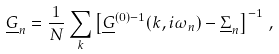<formula> <loc_0><loc_0><loc_500><loc_500>\underline { G } _ { n } = \frac { 1 } { N } \sum _ { k } \left [ \underline { G } ^ { ( 0 ) - 1 } ( { k } , i \omega _ { n } ) - \underline { \Sigma } _ { n } \right ] ^ { - 1 } \, ,</formula> 